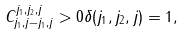<formula> <loc_0><loc_0><loc_500><loc_500>C _ { j _ { 1 } , j - j _ { 1 } , j } ^ { j _ { 1 } , j _ { 2 } , j } > 0 \delta ( j _ { 1 } , j _ { 2 } , j ) = 1 ,</formula> 